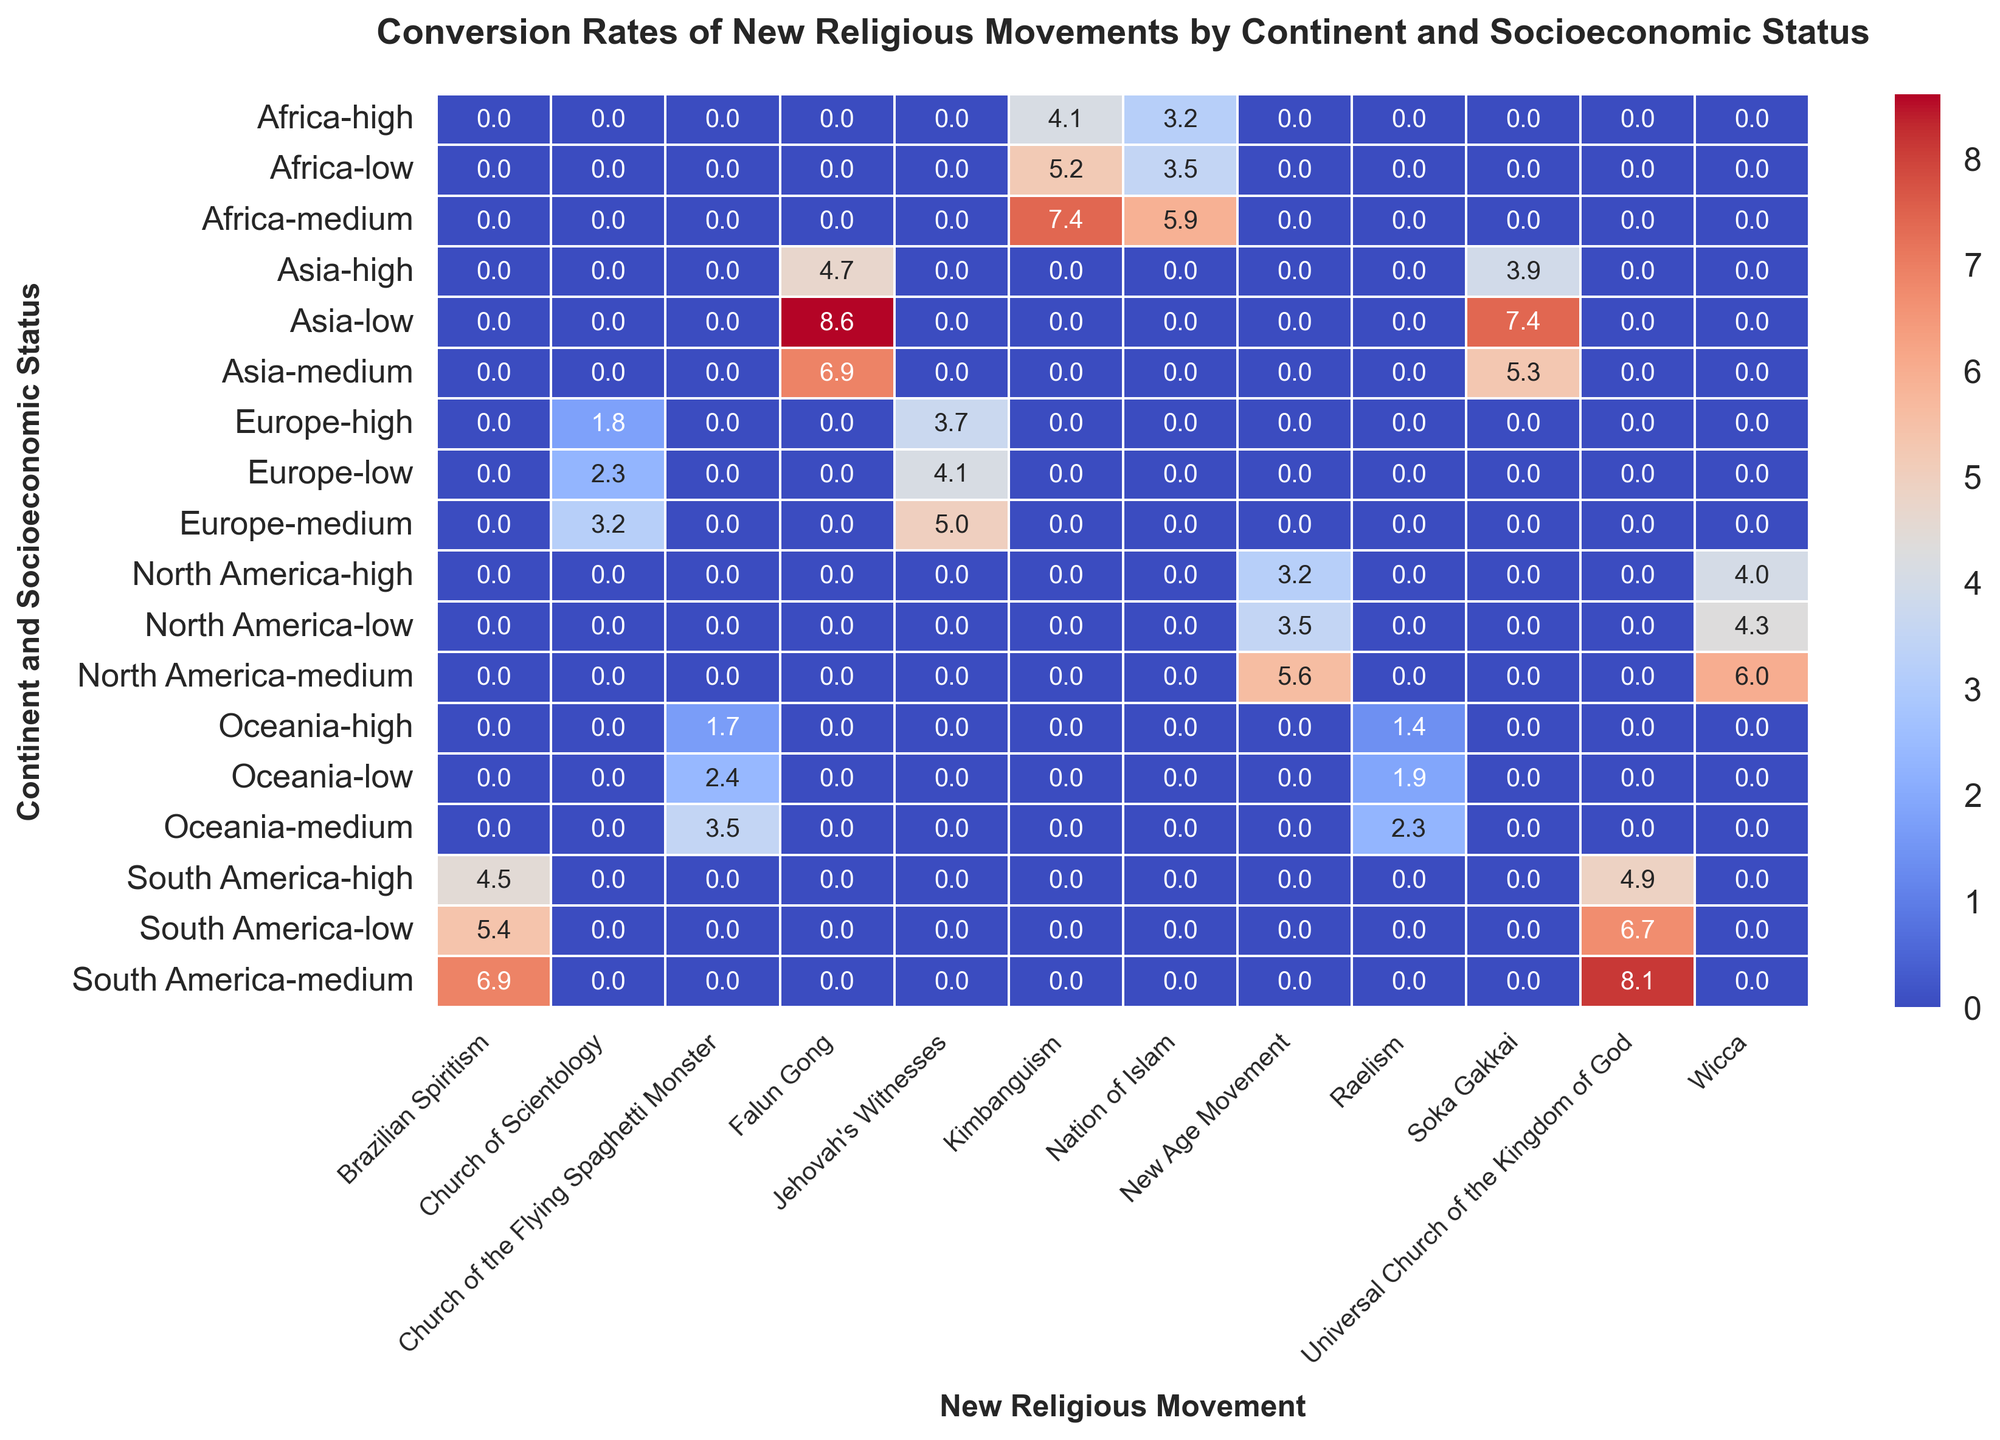What's the highest conversion rate for the "Universal Church of the Kingdom of God"? To find the highest conversion rate, look at the values under the "Universal Church of the Kingdom of God" column. The highest value is 8.1 in the South America, medium socioeconomic status cell.
Answer: 8.1 Which continent has the highest conversion rate for "Falun Gong"? Compare the conversion rates for "Falun Gong" across different continents. The values are: Africa (N/A), Asia (8.6 low, 6.9 medium, 4.7 high), Europe (N/A), North America (N/A), South America (N/A), Oceania (N/A). Asia has the highest conversion rate of 8.6.
Answer: Asia Is the conversion rate for "Soka Gakkai" higher in low or medium socioeconomic statuses in Asia? Look at the "Soka Gakkai" column under Asia. The conversion rate for low socioeconomic status is 7.4 and for medium socioeconomic status is 5.3. So, it is higher in low.
Answer: Low What's the difference in conversion rates between "New Age Movement" and "Wicca" in North America, medium socioeconomic status? Look at the values in the columns for "New Age Movement" and "Wicca" under North America, medium socioeconomic rows. The conversion rates are 5.6 and 6.0, respectively. The difference is 6.0 - 5.6 = 0.4.
Answer: 0.4 Which new religious movement has the lowest conversion rate in Oceania? Compare the conversion rates in the columns for the new religious movements under Oceania. The lowest value is Raelism in high socioeconomic status with 1.4.
Answer: Raelism What is the average conversion rate for "Kimbanguism" in Africa? Sum the conversion rates for "Kimbanguism" in Africa (5.2 low, 7.4 medium, 4.1 high) and divide by the number of socioeconomic statuses. The sum is 5.2 + 7.4 + 4.1 = 16.7. The number of statuses is 3, so the average is 16.7 / 3 = 5.57.
Answer: 5.57 How does the conversion rate of "Church of Scientology" in Europe, high socioeconomic status compare to that in medium socioeconomic status? Compare the values in the "Church of Scientology" column for Europe. The conversion rate in high socioeconomic status is 1.8 and in medium socioeconomic status it is 3.2. So, it is lower in high socioeconomic status.
Answer: Lower Is the conversion rate of "Jehovah's Witnesses" higher in low or high socioeconomic statuses in Europe? Look at the "Jehovah's Witnesses" column for Europe. The conversion rate for low socioeconomic status is 4.1 and for high socioeconomic status is 3.7. Thus, it is higher in low.
Answer: Low What's the sum of conversion rates for "Brazilian Spiritism" across all socioeconomic statuses in South America? Add the conversion rates of "Brazilian Spiritism" in South America (low, medium, high). The values are 5.4, 6.9, and 4.5. The sum is 5.4 + 6.9 + 4.5 = 16.8.
Answer: 16.8 What is the range of conversion rates for "Church of the Flying Spaghetti Monster" in Oceania? Find the minimum and maximum values for "Church of the Flying Spaghetti Monster" in Oceania. The values are 2.4 (low), 3.5 (medium), and 1.7 (high). The range is 3.5 - 1.7 = 1.8.
Answer: 1.8 